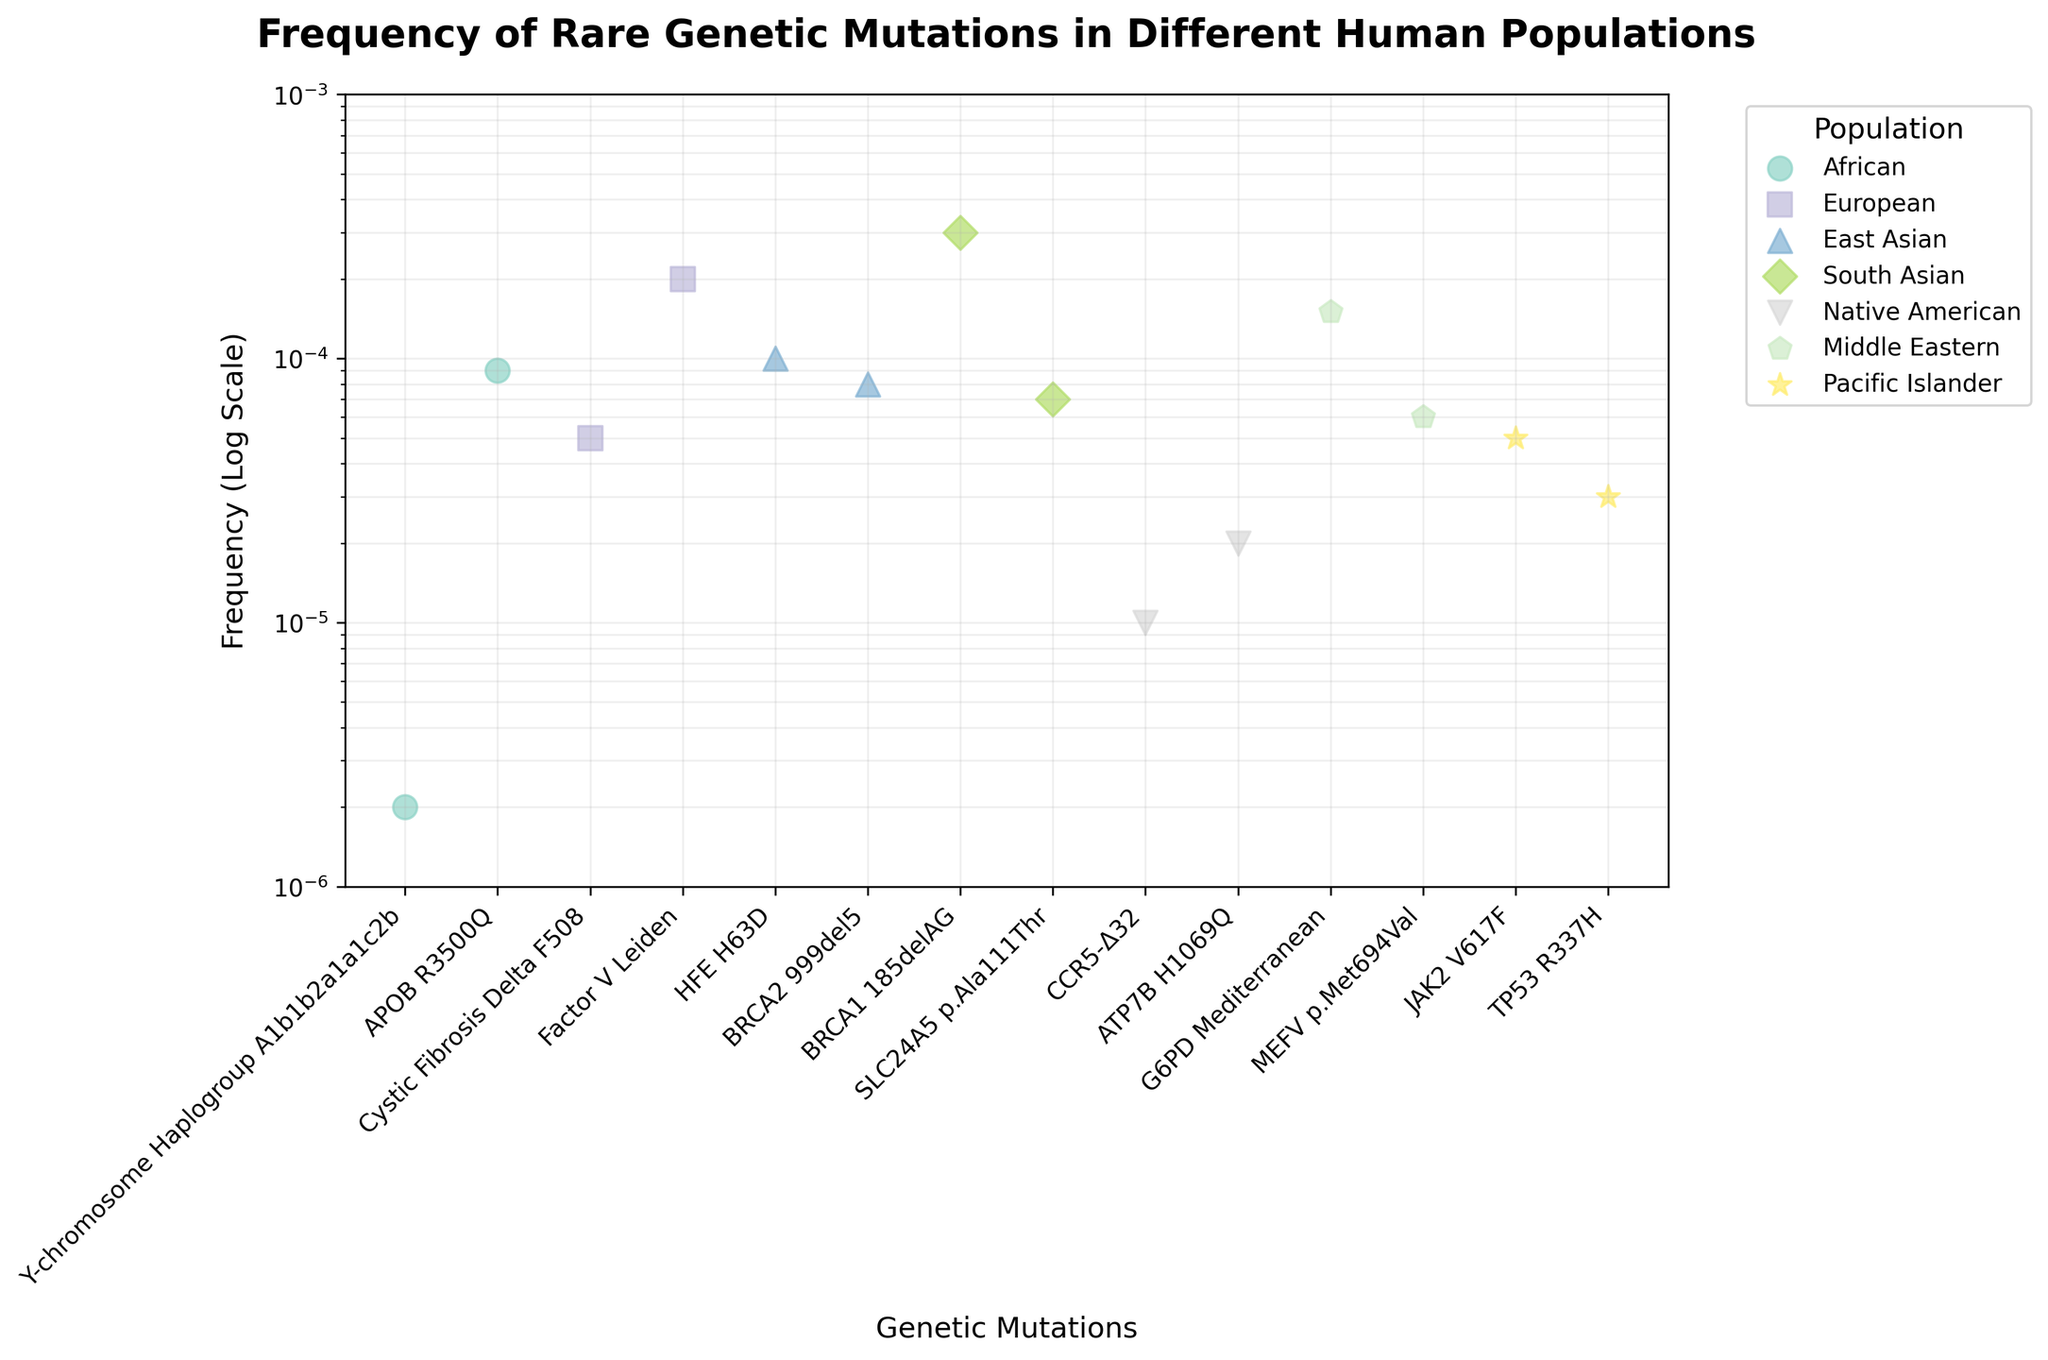What's the title of the figure? The title of the figure is displayed at the top and typically summarizes the main topic of the plot.
Answer: Frequency of Rare Genetic Mutations in Different Human Populations What does the y-axis represent? The y-axis represents the frequency of the genetic mutations and is marked with a label. The scale is logarithmic, which can be inferred from the evenly spaced tick marks despite the exponential difference in their values.
Answer: Frequency (Log Scale) Which population has the mutation with the lowest frequency? To find the lowest frequency, identify the point at the lowest position along the log scale on the y-axis. The African population has the lowest data point.
Answer: African How many data points exist for the African population? Each population has different markers. By counting the markers associated with the African population, we find there are two such points.
Answer: 2 What's the frequency of the BRCA1 185delAG mutation in South Asians? Locate the label "BRCA1 185delAG" along the x-axis and follow it up to the corresponding data point, then refer to the y-axis to find its frequency value.
Answer: 0.0003 Which genetic mutation has the highest frequency in the Middle Eastern population? Identify the points labeled for the Middle Eastern population and check their y-axis values. The higher point has a frequency label at around 0.00015 for the G6PD Mediterranean mutation.
Answer: G6PD Mediterranean Compare the frequency of the BRCA2 999del5 mutation in East Asians with the TP53 R337H mutation in Pacific Islanders. Which is higher and by how much? BRCA2 999del5 has a frequency of 0.00008 for East Asians. TP53 R337H has a frequency of 0.00003 for Pacific Islanders. Subtract the smaller frequency from the larger one to determine the difference.
Answer: BRCA2 999del5 is higher by 0.00005 Which populations have genetic mutations with frequencies below 0.00005? Identify data points that lie below the 0.00005 mark on the y-axis and check which populations they belong to. The African, Native American, and Pacific Islander populations meet this criterion.
Answer: African, Native American, Pacific Islander On average, what is the frequency of the genetic mutations in Europeans? Locate European population markers and calculate the mean of their frequencies: (0.00005 for Cystic Fibrosis Delta F508 + 0.0002 for Factor V Leiden) / 2.
Answer: 0.000125 What range does the y-axis cover and why is a logarithmic scale used? The range is from 1e-6 to 1e-3. A logarithmic scale is used to handle the wide range of frequencies, allowing for a more readable comparison of data points that vary by several orders of magnitude.
Answer: From 1e-6 to 1e-3, to accommodate a wide range of values 